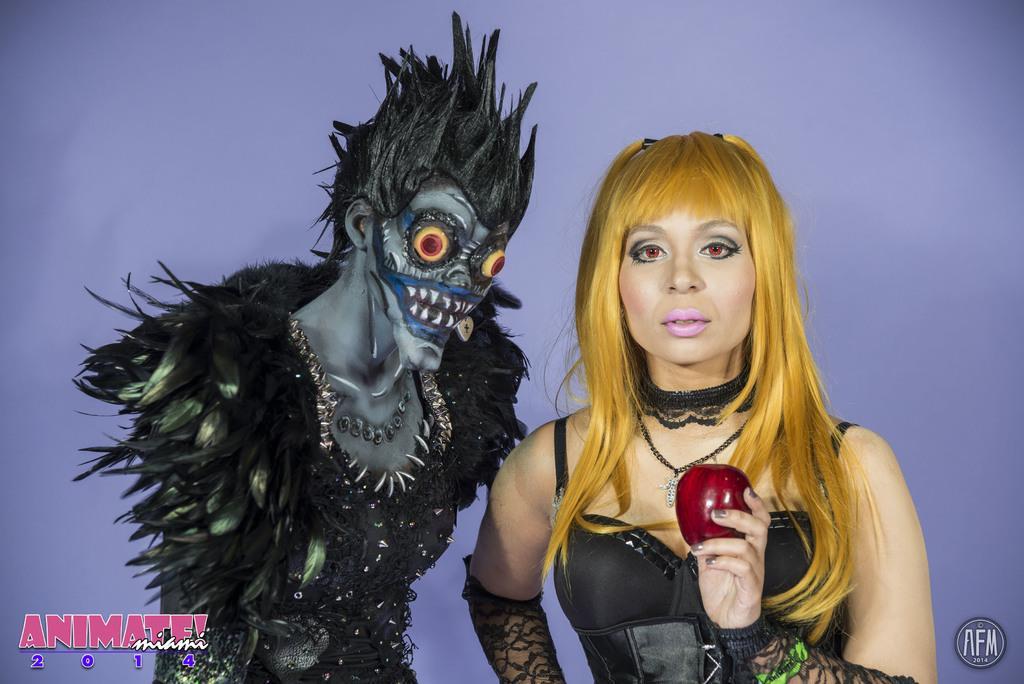Please provide a concise description of this image. There is one woman standing and holding an apple on the right side of this image, and there is one other person standing and wearing a costume on the left side of this image. There is a blue color wall in the background. There is a logo in the bottom left corner of this image, and bottom right corner of this image as well. 